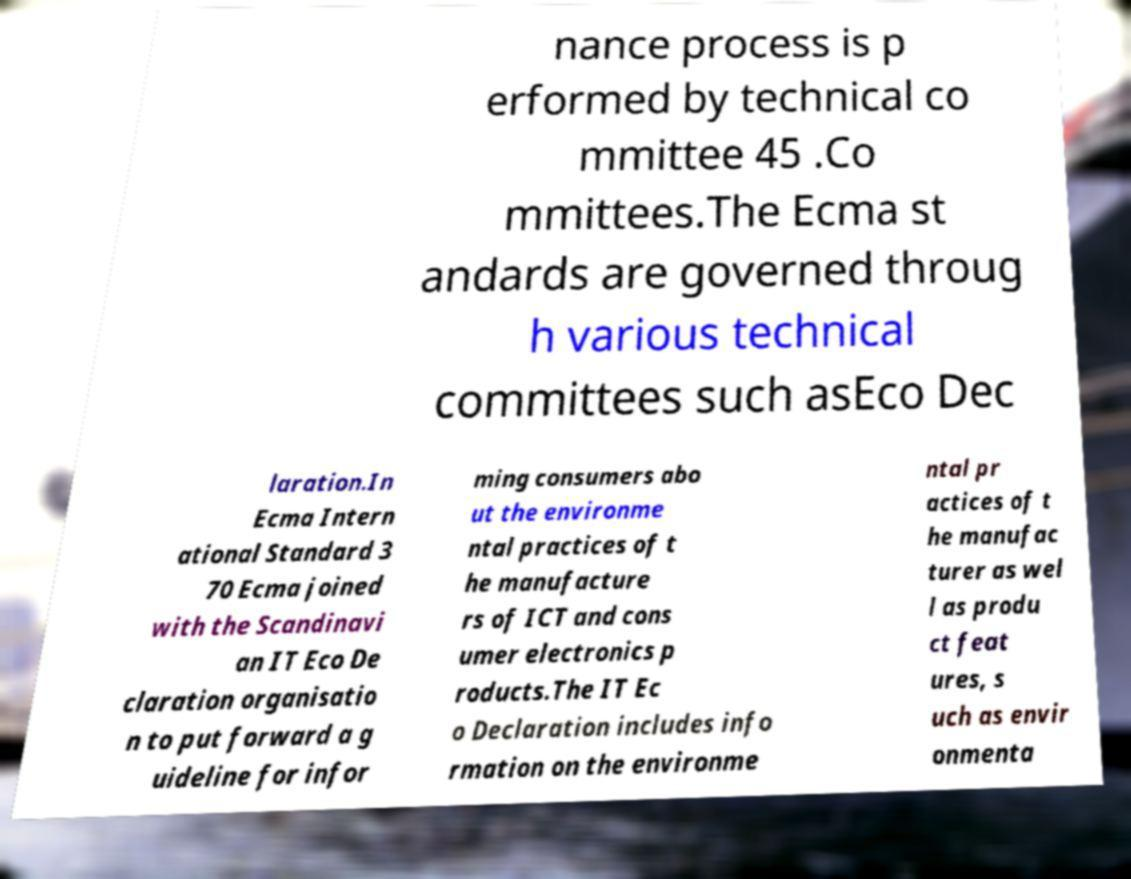Please read and relay the text visible in this image. What does it say? nance process is p erformed by technical co mmittee 45 .Co mmittees.The Ecma st andards are governed throug h various technical committees such asEco Dec laration.In Ecma Intern ational Standard 3 70 Ecma joined with the Scandinavi an IT Eco De claration organisatio n to put forward a g uideline for infor ming consumers abo ut the environme ntal practices of t he manufacture rs of ICT and cons umer electronics p roducts.The IT Ec o Declaration includes info rmation on the environme ntal pr actices of t he manufac turer as wel l as produ ct feat ures, s uch as envir onmenta 